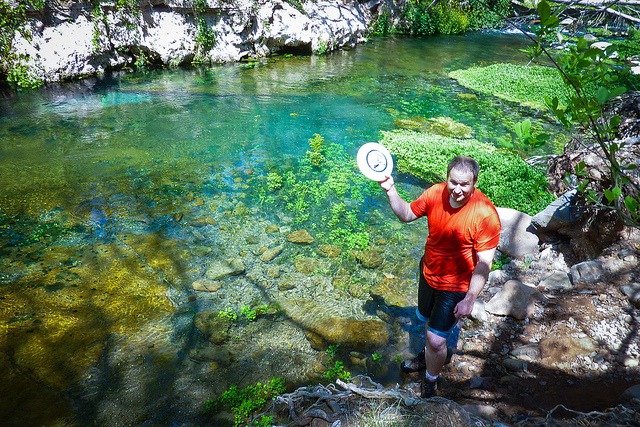Can you tell what activity the man in the image might be engaging in? The man appears to be wading through a shallow river or stream, possibly enjoying the natural setting or cooling off on a warm day. He's holding a hat, which suggests a leisurely outing. 